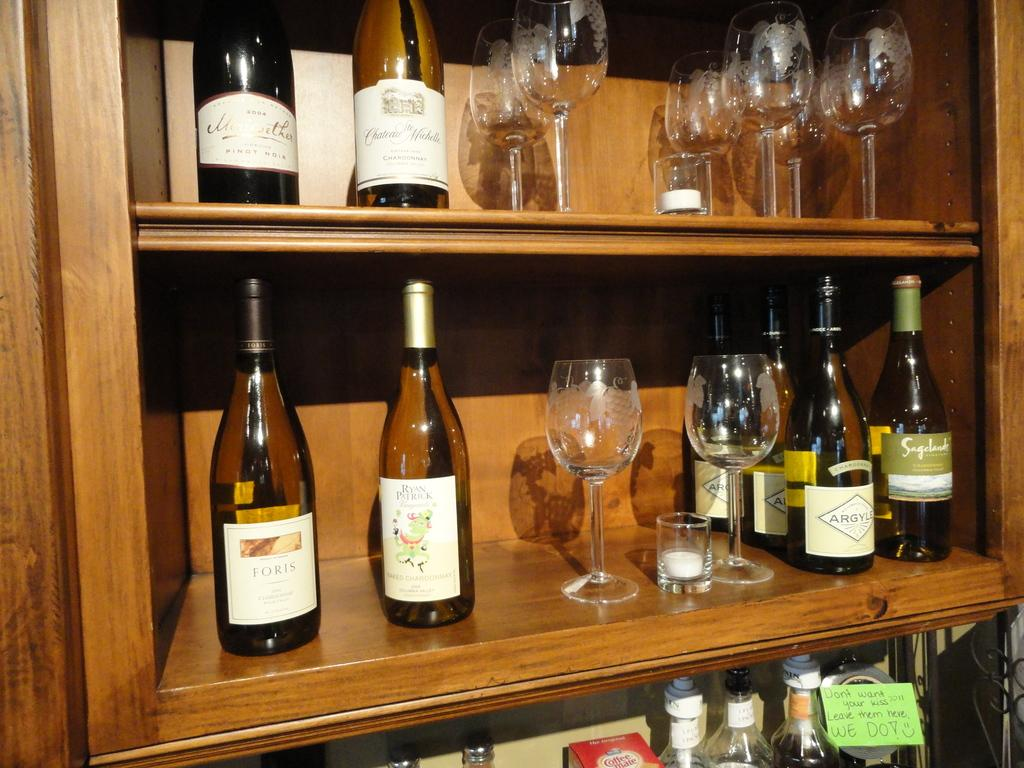<image>
Provide a brief description of the given image. The green sign states to leave your wine glass there. 